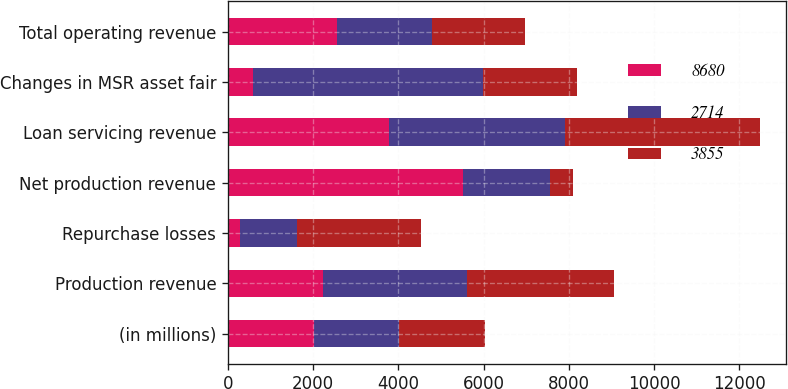Convert chart to OTSL. <chart><loc_0><loc_0><loc_500><loc_500><stacked_bar_chart><ecel><fcel>(in millions)<fcel>Production revenue<fcel>Repurchase losses<fcel>Net production revenue<fcel>Loan servicing revenue<fcel>Changes in MSR asset fair<fcel>Total operating revenue<nl><fcel>8680<fcel>2012<fcel>2224<fcel>272<fcel>5511<fcel>3772<fcel>587<fcel>2550<nl><fcel>2714<fcel>2011<fcel>3395<fcel>1347<fcel>2048<fcel>4134<fcel>5390<fcel>2230<nl><fcel>3855<fcel>2010<fcel>3440<fcel>2912<fcel>528<fcel>4575<fcel>2224<fcel>2191<nl></chart> 